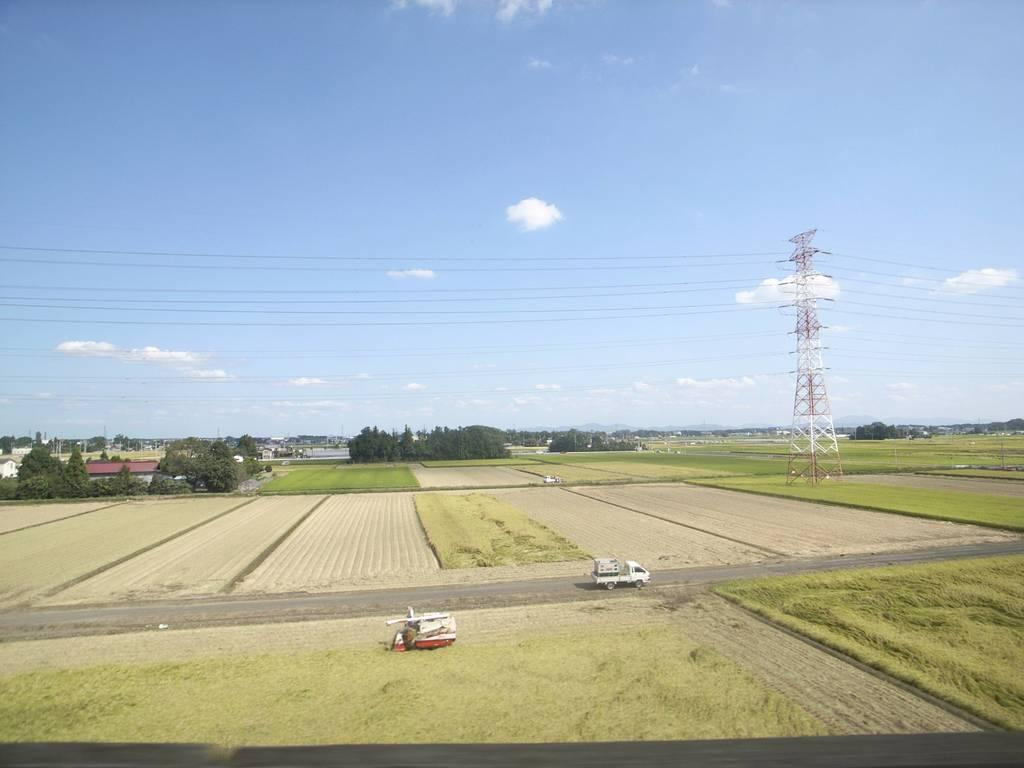What can be seen on the road in the image? There are vehicles on the road in the image. What tall structure is present in the image? There is a tower in the image. What are the wires connected to in the image? The wires are connected to poles in the image. What type of vegetation is visible in the image? Trees are in the image. What is the color of the sky in the image? The sky is white and blue in color. What type of reward is being offered to the trees in the image? There is no reward being offered to the trees in the image; they are simply part of the natural landscape. What type of skin condition is visible on the tower in the image? There is no skin condition visible on the tower in the image, as it is a man-made structure. 